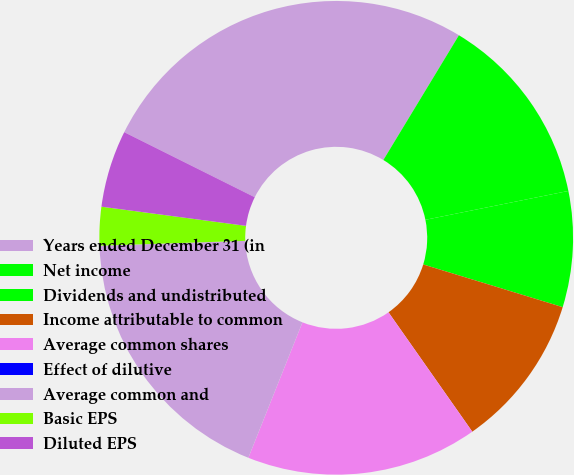Convert chart to OTSL. <chart><loc_0><loc_0><loc_500><loc_500><pie_chart><fcel>Years ended December 31 (in<fcel>Net income<fcel>Dividends and undistributed<fcel>Income attributable to common<fcel>Average common shares<fcel>Effect of dilutive<fcel>Average common and<fcel>Basic EPS<fcel>Diluted EPS<nl><fcel>26.31%<fcel>13.16%<fcel>7.9%<fcel>10.53%<fcel>15.79%<fcel>0.0%<fcel>18.42%<fcel>2.63%<fcel>5.26%<nl></chart> 